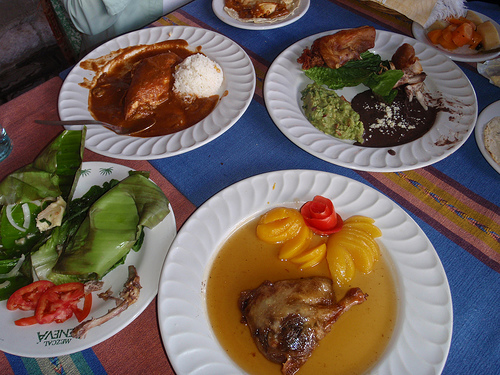<image>
Can you confirm if the plate is on the table? Yes. Looking at the image, I can see the plate is positioned on top of the table, with the table providing support. 